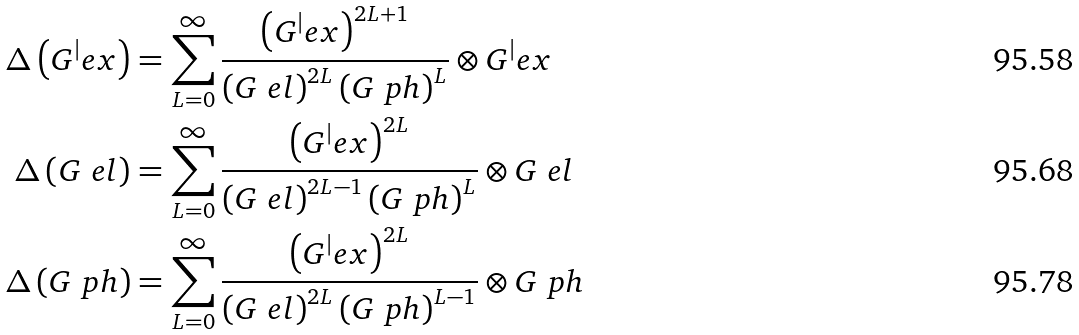<formula> <loc_0><loc_0><loc_500><loc_500>\Delta \left ( G ^ { | } e x \right ) & = \sum _ { L = 0 } ^ { \infty } \frac { \left ( G ^ { | } e x \right ) ^ { 2 L + 1 } } { \left ( G ^ { \ } e l \right ) ^ { 2 L } \left ( G ^ { \ } p h \right ) ^ { L } } \otimes G ^ { | } e x \\ \Delta \left ( G ^ { \ } e l \right ) & = \sum _ { L = 0 } ^ { \infty } \frac { \left ( G ^ { | } e x \right ) ^ { 2 L } } { \left ( G ^ { \ } e l \right ) ^ { 2 L - 1 } \left ( G ^ { \ } p h \right ) ^ { L } } \otimes G ^ { \ } e l \\ \Delta \left ( G ^ { \ } p h \right ) & = \sum _ { L = 0 } ^ { \infty } \frac { \left ( G ^ { | } e x \right ) ^ { 2 L } } { \left ( G ^ { \ } e l \right ) ^ { 2 L } \left ( G ^ { \ } p h \right ) ^ { L - 1 } } \otimes G ^ { \ } p h</formula> 